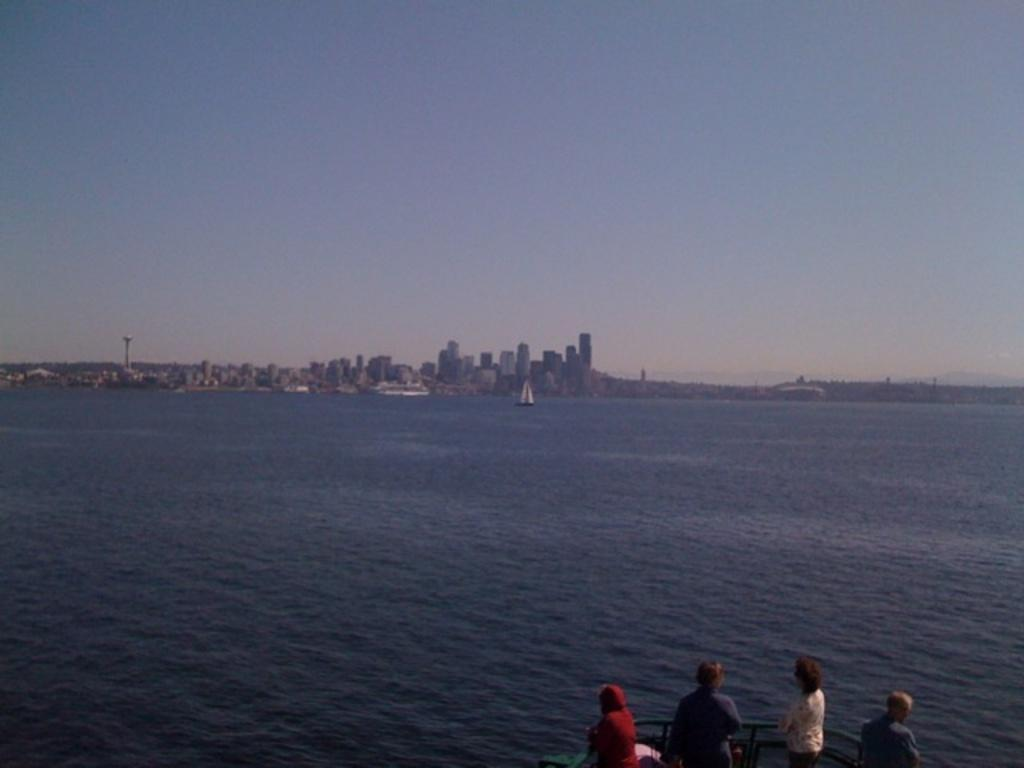What is the main subject in the foreground of the image? There is a sea in the foreground of the image, and four persons are on a boat. What can be seen in the background of the image? There are buildings, towers, trees, and the sky visible in the background of the image. Are there any clouds in the sky? Yes, there are clouds in the sky. Can you tell me how many pencils are being used by the persons on the boat? There is no mention of pencils in the image; the persons on the boat are not using any pencils. What type of finger can be seen interacting with the boat? There is no finger visible in the image, and no interaction with the boat is shown. 